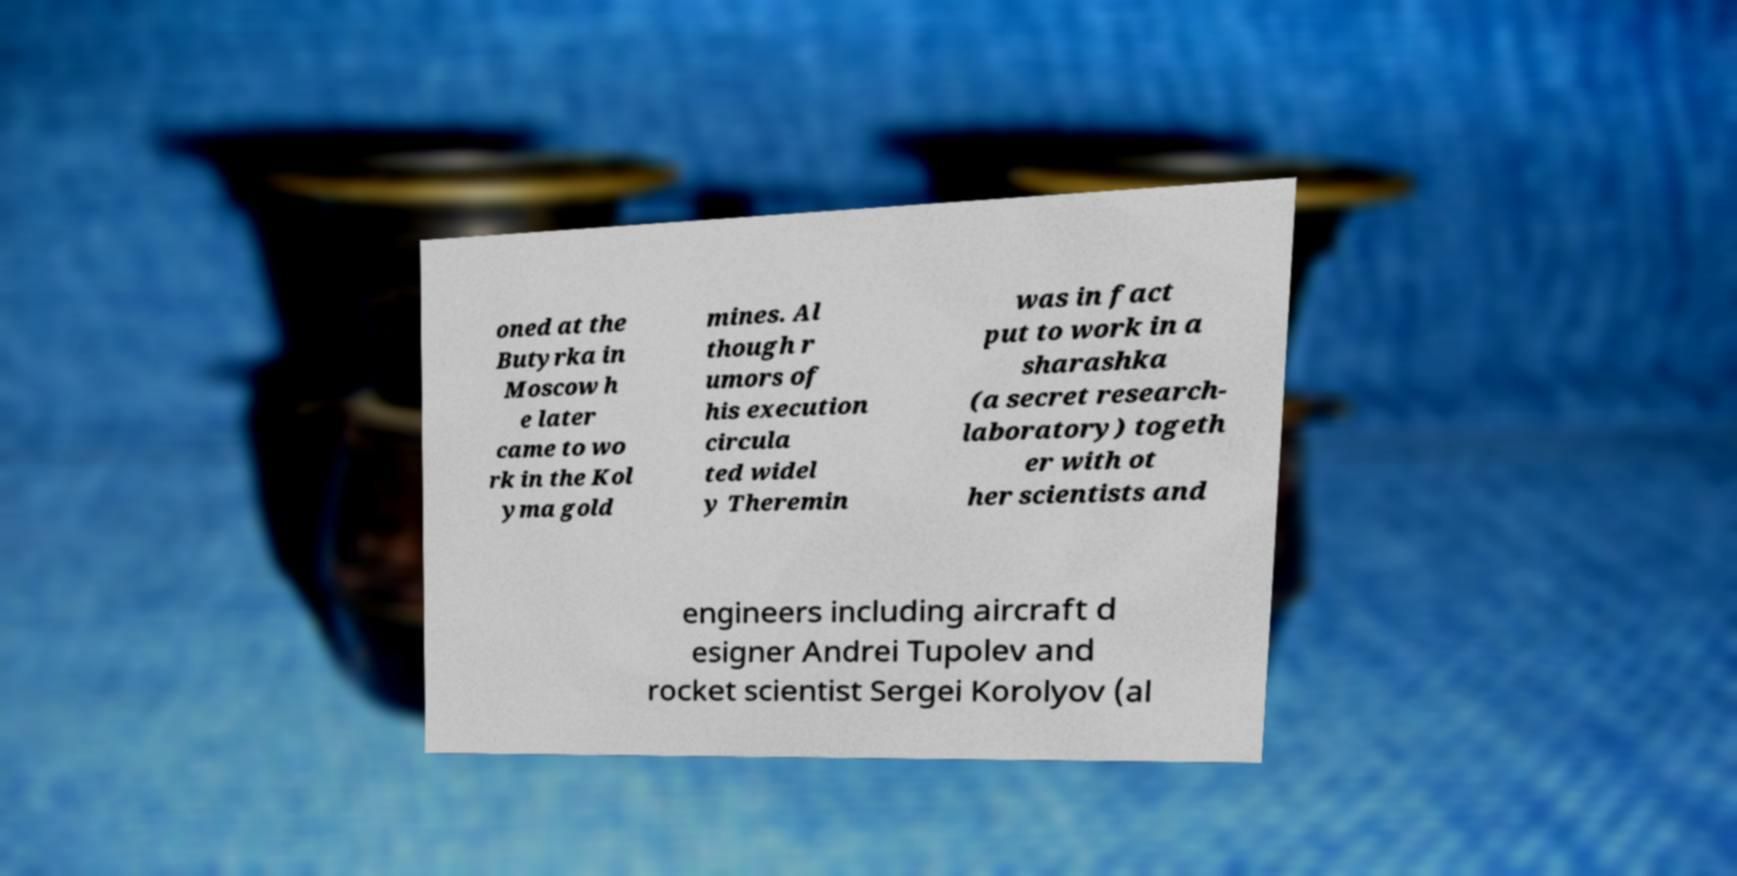Could you assist in decoding the text presented in this image and type it out clearly? oned at the Butyrka in Moscow h e later came to wo rk in the Kol yma gold mines. Al though r umors of his execution circula ted widel y Theremin was in fact put to work in a sharashka (a secret research- laboratory) togeth er with ot her scientists and engineers including aircraft d esigner Andrei Tupolev and rocket scientist Sergei Korolyov (al 